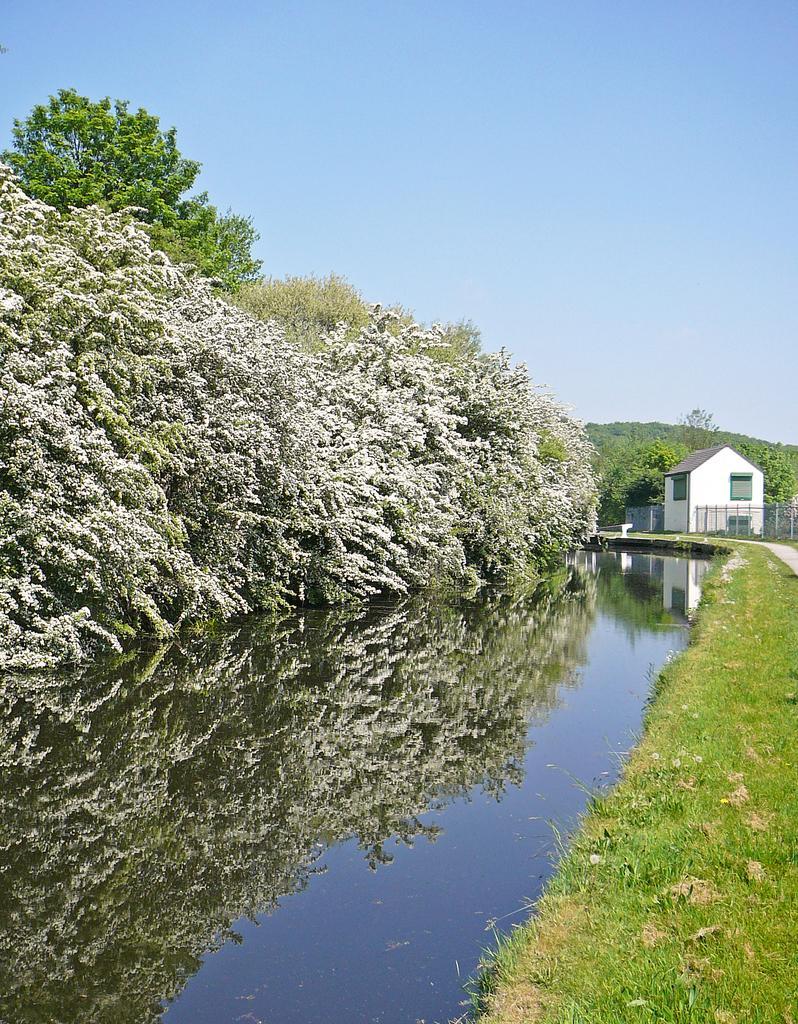How would you summarize this image in a sentence or two? This image consists of many trees. On the right, we can a small house along with windows. Beside that there is a fencing. At the bottom, there is water. On the right, we can see green grass on the ground. At the top, there is sky. 